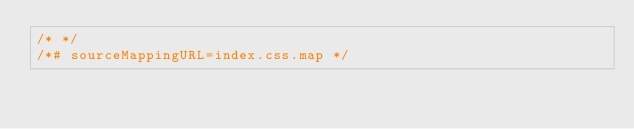Convert code to text. <code><loc_0><loc_0><loc_500><loc_500><_CSS_>/* */
/*# sourceMappingURL=index.css.map */</code> 